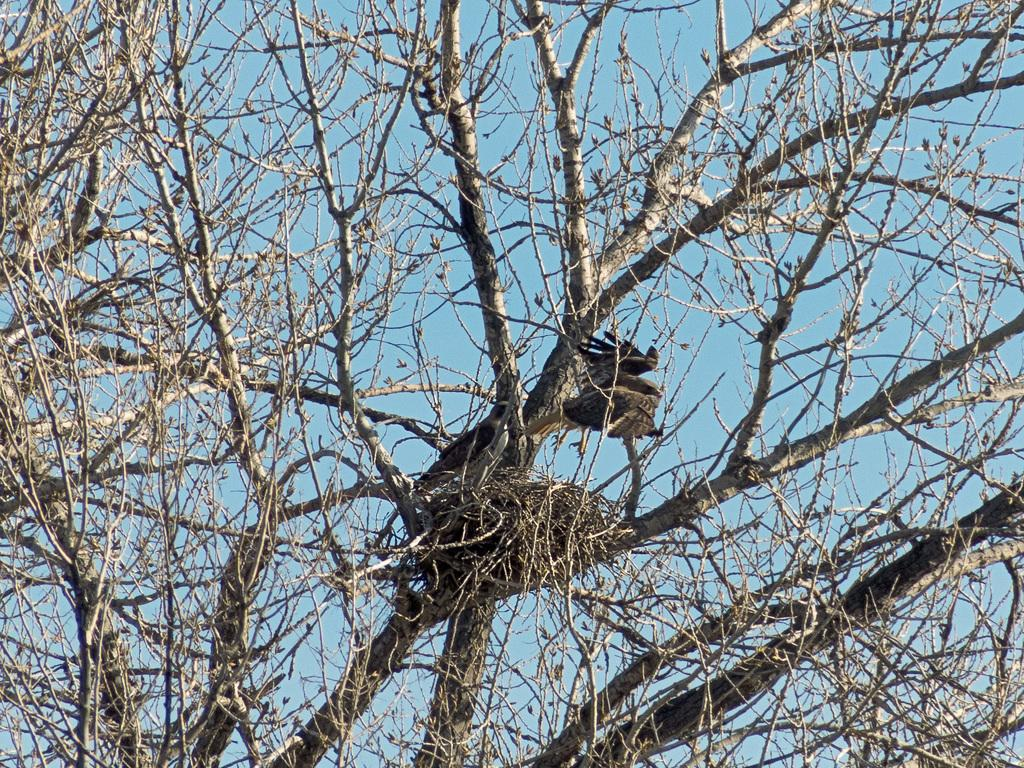What is located in the foreground of the image? There is a tree without leaves in the foreground of the image. What can be seen on the tree? There are two birds on the tree. Can you describe the activity of one of the birds? One of the birds is on a nest. What type of cream is being used by the birds to build the nest? There is no cream present in the image, and the birds are not using any cream to build the nest. 